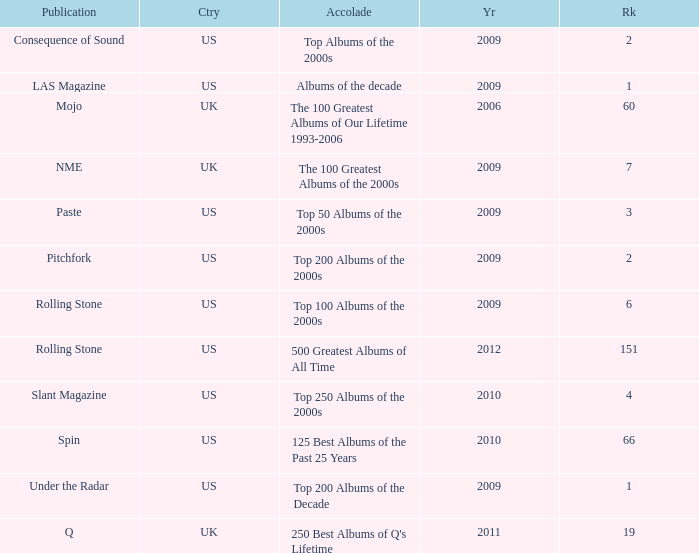What country had a paste publication in 2009? US. 